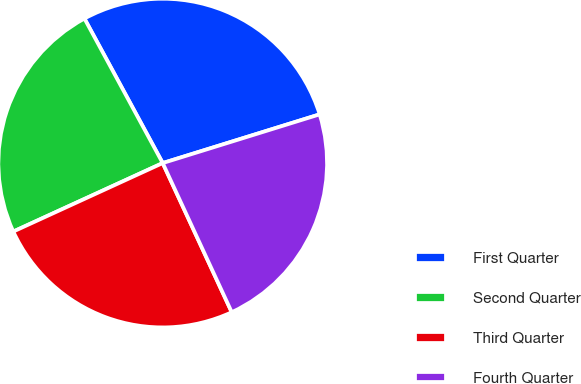<chart> <loc_0><loc_0><loc_500><loc_500><pie_chart><fcel>First Quarter<fcel>Second Quarter<fcel>Third Quarter<fcel>Fourth Quarter<nl><fcel>28.11%<fcel>23.94%<fcel>25.06%<fcel>22.89%<nl></chart> 